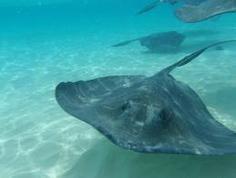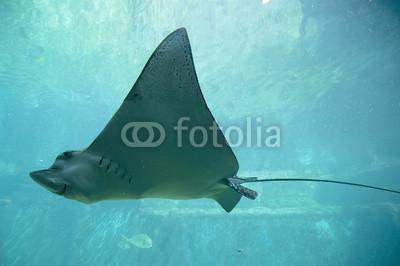The first image is the image on the left, the second image is the image on the right. For the images shown, is this caption "Each image contains a single stingray, and the stingrays in the right and left images face opposite direction." true? Answer yes or no. No. The first image is the image on the left, the second image is the image on the right. Evaluate the accuracy of this statement regarding the images: "The left image contains a sting ray that is swimming slightly upwards towards the right.". Is it true? Answer yes or no. No. 